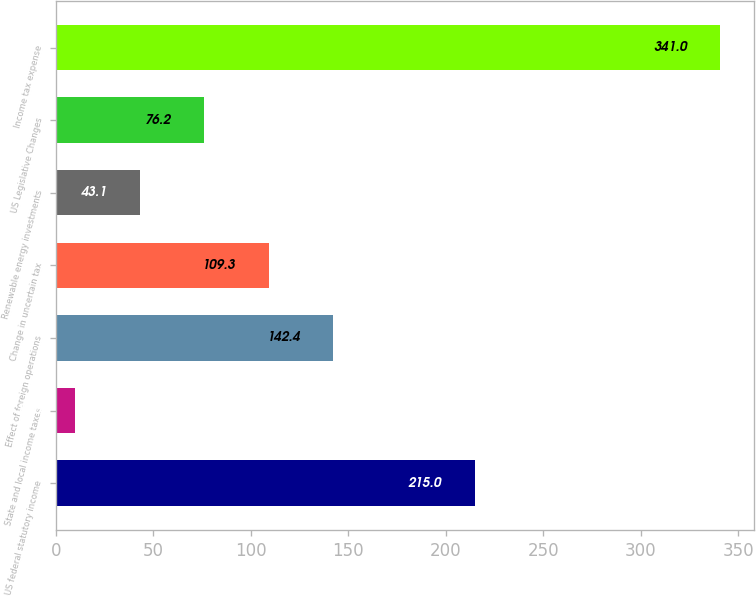Convert chart to OTSL. <chart><loc_0><loc_0><loc_500><loc_500><bar_chart><fcel>US federal statutory income<fcel>State and local income taxes<fcel>Effect of foreign operations<fcel>Change in uncertain tax<fcel>Renewable energy investments<fcel>US Legislative Changes<fcel>Income tax expense<nl><fcel>215<fcel>10<fcel>142.4<fcel>109.3<fcel>43.1<fcel>76.2<fcel>341<nl></chart> 